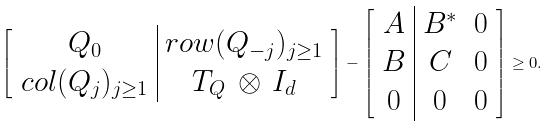<formula> <loc_0><loc_0><loc_500><loc_500>\begin{bmatrix} \begin{array} { c | c } Q _ { 0 } & r o w ( Q _ { - j } ) _ { j \geq 1 } \\ c o l ( Q _ { j } ) _ { j \geq 1 } & T _ { Q } \, \otimes \, I _ { d } \end{array} \end{bmatrix} - \begin{bmatrix} \begin{array} { c | c c } A & B ^ { * } & 0 \\ B & C & 0 \\ 0 & 0 & 0 \end{array} \end{bmatrix} \geq 0 .</formula> 